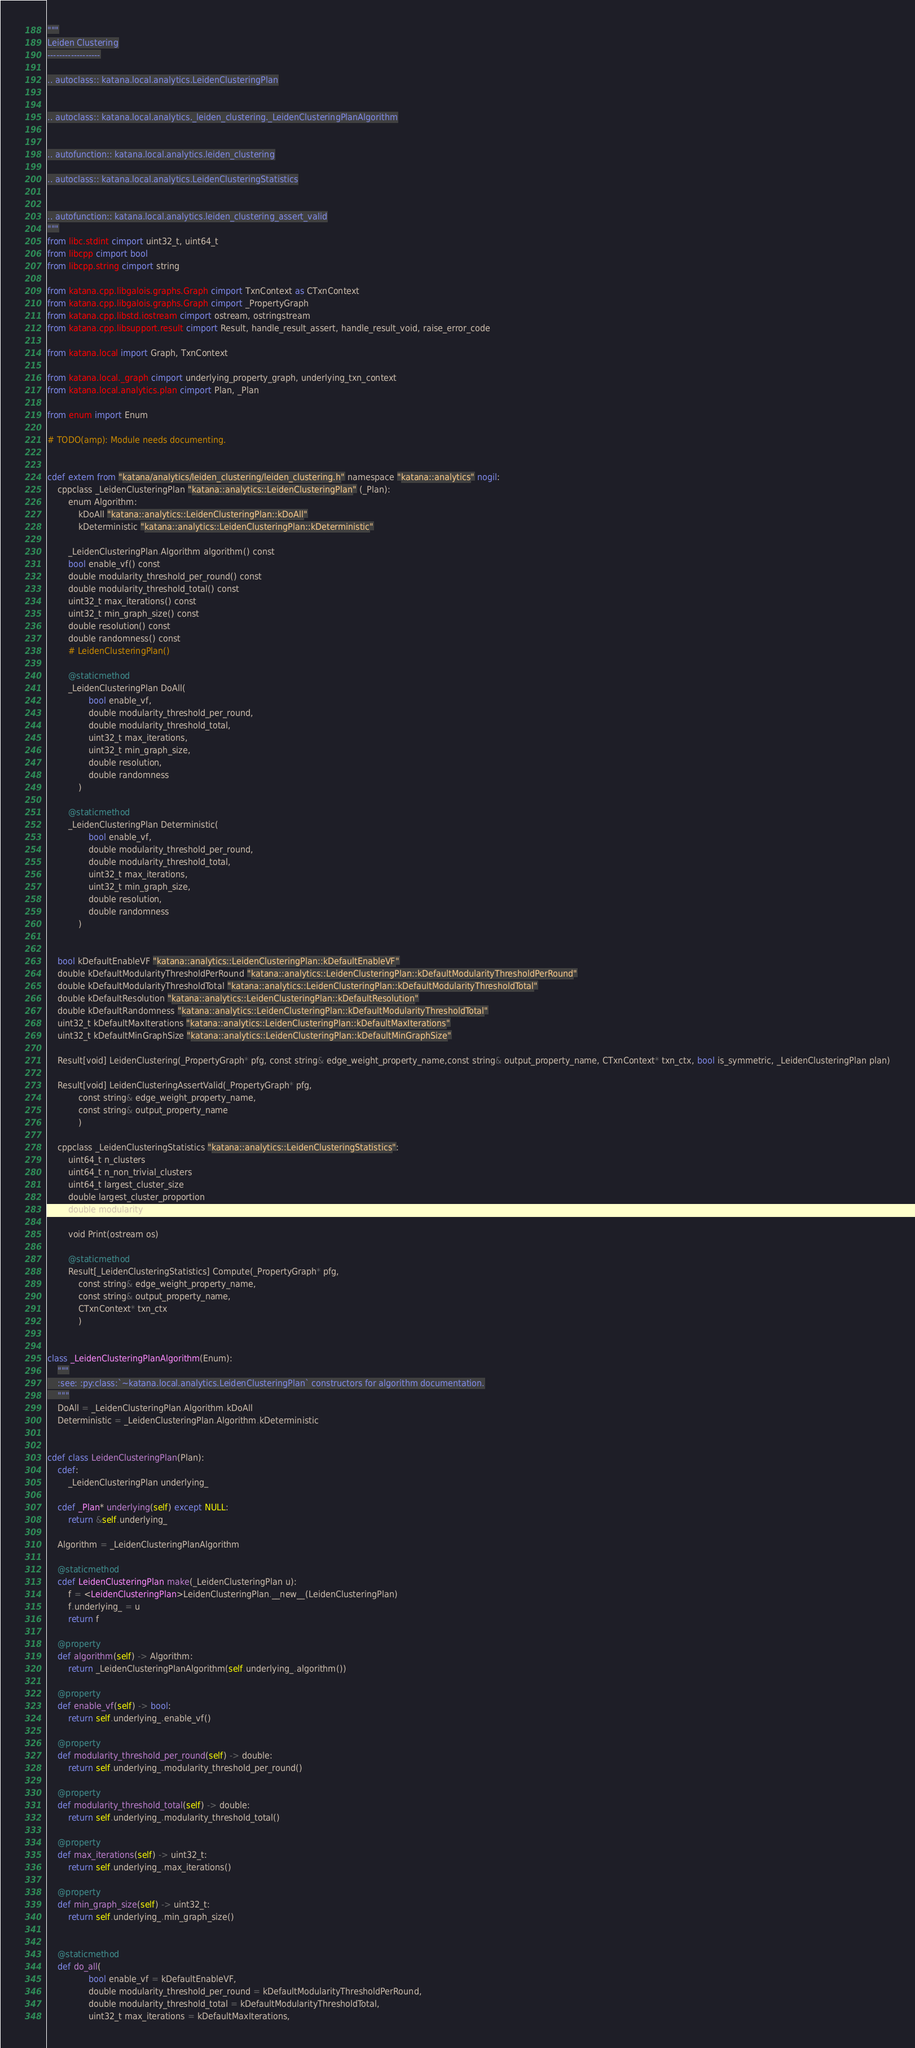Convert code to text. <code><loc_0><loc_0><loc_500><loc_500><_Cython_>"""
Leiden Clustering
------------------

.. autoclass:: katana.local.analytics.LeidenClusteringPlan


.. autoclass:: katana.local.analytics._leiden_clustering._LeidenClusteringPlanAlgorithm


.. autofunction:: katana.local.analytics.leiden_clustering

.. autoclass:: katana.local.analytics.LeidenClusteringStatistics


.. autofunction:: katana.local.analytics.leiden_clustering_assert_valid
"""
from libc.stdint cimport uint32_t, uint64_t
from libcpp cimport bool
from libcpp.string cimport string

from katana.cpp.libgalois.graphs.Graph cimport TxnContext as CTxnContext
from katana.cpp.libgalois.graphs.Graph cimport _PropertyGraph
from katana.cpp.libstd.iostream cimport ostream, ostringstream
from katana.cpp.libsupport.result cimport Result, handle_result_assert, handle_result_void, raise_error_code

from katana.local import Graph, TxnContext

from katana.local._graph cimport underlying_property_graph, underlying_txn_context
from katana.local.analytics.plan cimport Plan, _Plan

from enum import Enum

# TODO(amp): Module needs documenting.


cdef extern from "katana/analytics/leiden_clustering/leiden_clustering.h" namespace "katana::analytics" nogil:
    cppclass _LeidenClusteringPlan "katana::analytics::LeidenClusteringPlan" (_Plan):
        enum Algorithm:
            kDoAll "katana::analytics::LeidenClusteringPlan::kDoAll"
            kDeterministic "katana::analytics::LeidenClusteringPlan::kDeterministic"

        _LeidenClusteringPlan.Algorithm algorithm() const
        bool enable_vf() const
        double modularity_threshold_per_round() const
        double modularity_threshold_total() const
        uint32_t max_iterations() const
        uint32_t min_graph_size() const
        double resolution() const
        double randomness() const
        # LeidenClusteringPlan()

        @staticmethod
        _LeidenClusteringPlan DoAll(
                bool enable_vf,
                double modularity_threshold_per_round,
                double modularity_threshold_total,
                uint32_t max_iterations,
                uint32_t min_graph_size,
                double resolution,
                double randomness
            )

        @staticmethod
        _LeidenClusteringPlan Deterministic(
                bool enable_vf,
                double modularity_threshold_per_round,
                double modularity_threshold_total,
                uint32_t max_iterations,
                uint32_t min_graph_size,
                double resolution,
                double randomness
            )


    bool kDefaultEnableVF "katana::analytics::LeidenClusteringPlan::kDefaultEnableVF"
    double kDefaultModularityThresholdPerRound "katana::analytics::LeidenClusteringPlan::kDefaultModularityThresholdPerRound"
    double kDefaultModularityThresholdTotal "katana::analytics::LeidenClusteringPlan::kDefaultModularityThresholdTotal"
    double kDefaultResolution "katana::analytics::LeidenClusteringPlan::kDefaultResolution"
    double kDefaultRandomness "katana::analytics::LeidenClusteringPlan::kDefaultModularityThresholdTotal"
    uint32_t kDefaultMaxIterations "katana::analytics::LeidenClusteringPlan::kDefaultMaxIterations"
    uint32_t kDefaultMinGraphSize "katana::analytics::LeidenClusteringPlan::kDefaultMinGraphSize"

    Result[void] LeidenClustering(_PropertyGraph* pfg, const string& edge_weight_property_name,const string& output_property_name, CTxnContext* txn_ctx, bool is_symmetric, _LeidenClusteringPlan plan)

    Result[void] LeidenClusteringAssertValid(_PropertyGraph* pfg,
            const string& edge_weight_property_name,
            const string& output_property_name
            )

    cppclass _LeidenClusteringStatistics "katana::analytics::LeidenClusteringStatistics":
        uint64_t n_clusters
        uint64_t n_non_trivial_clusters
        uint64_t largest_cluster_size
        double largest_cluster_proportion
        double modularity

        void Print(ostream os)

        @staticmethod
        Result[_LeidenClusteringStatistics] Compute(_PropertyGraph* pfg,
            const string& edge_weight_property_name,
            const string& output_property_name,
            CTxnContext* txn_ctx
            )


class _LeidenClusteringPlanAlgorithm(Enum):
    """
    :see: :py:class:`~katana.local.analytics.LeidenClusteringPlan` constructors for algorithm documentation.
    """
    DoAll = _LeidenClusteringPlan.Algorithm.kDoAll
    Deterministic = _LeidenClusteringPlan.Algorithm.kDeterministic


cdef class LeidenClusteringPlan(Plan):
    cdef:
        _LeidenClusteringPlan underlying_

    cdef _Plan* underlying(self) except NULL:
        return &self.underlying_

    Algorithm = _LeidenClusteringPlanAlgorithm

    @staticmethod
    cdef LeidenClusteringPlan make(_LeidenClusteringPlan u):
        f = <LeidenClusteringPlan>LeidenClusteringPlan.__new__(LeidenClusteringPlan)
        f.underlying_ = u
        return f

    @property
    def algorithm(self) -> Algorithm:
        return _LeidenClusteringPlanAlgorithm(self.underlying_.algorithm())

    @property
    def enable_vf(self) -> bool:
        return self.underlying_.enable_vf()

    @property
    def modularity_threshold_per_round(self) -> double:
        return self.underlying_.modularity_threshold_per_round()

    @property
    def modularity_threshold_total(self) -> double:
        return self.underlying_.modularity_threshold_total()

    @property
    def max_iterations(self) -> uint32_t:
        return self.underlying_.max_iterations()

    @property
    def min_graph_size(self) -> uint32_t:
        return self.underlying_.min_graph_size()


    @staticmethod
    def do_all(
                bool enable_vf = kDefaultEnableVF,
                double modularity_threshold_per_round = kDefaultModularityThresholdPerRound,
                double modularity_threshold_total = kDefaultModularityThresholdTotal,
                uint32_t max_iterations = kDefaultMaxIterations,</code> 